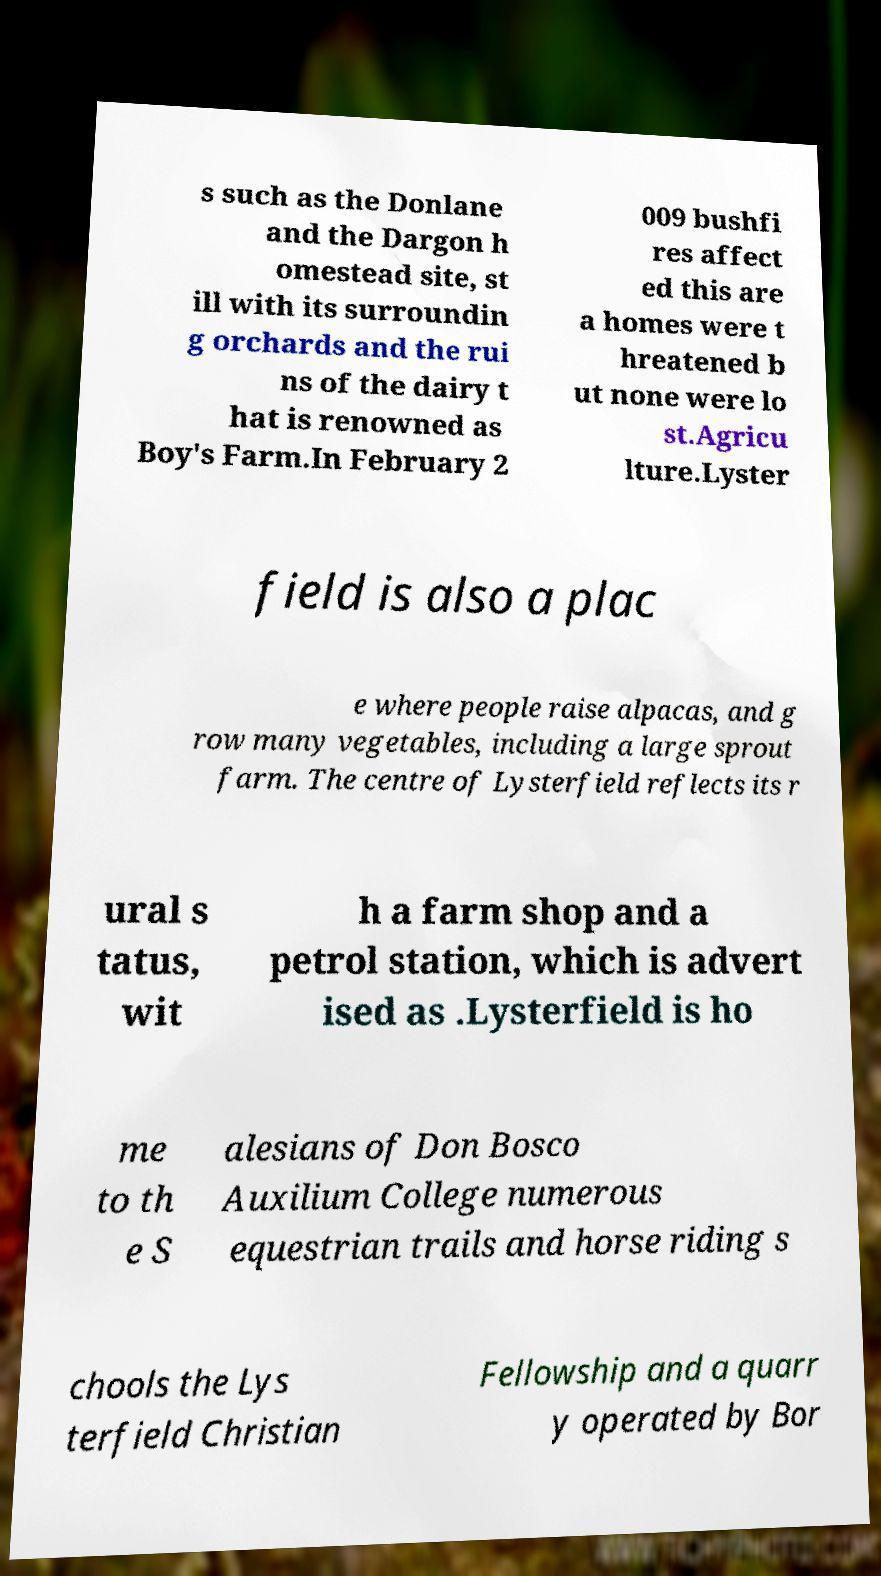Please identify and transcribe the text found in this image. s such as the Donlane and the Dargon h omestead site, st ill with its surroundin g orchards and the rui ns of the dairy t hat is renowned as Boy's Farm.In February 2 009 bushfi res affect ed this are a homes were t hreatened b ut none were lo st.Agricu lture.Lyster field is also a plac e where people raise alpacas, and g row many vegetables, including a large sprout farm. The centre of Lysterfield reflects its r ural s tatus, wit h a farm shop and a petrol station, which is advert ised as .Lysterfield is ho me to th e S alesians of Don Bosco Auxilium College numerous equestrian trails and horse riding s chools the Lys terfield Christian Fellowship and a quarr y operated by Bor 